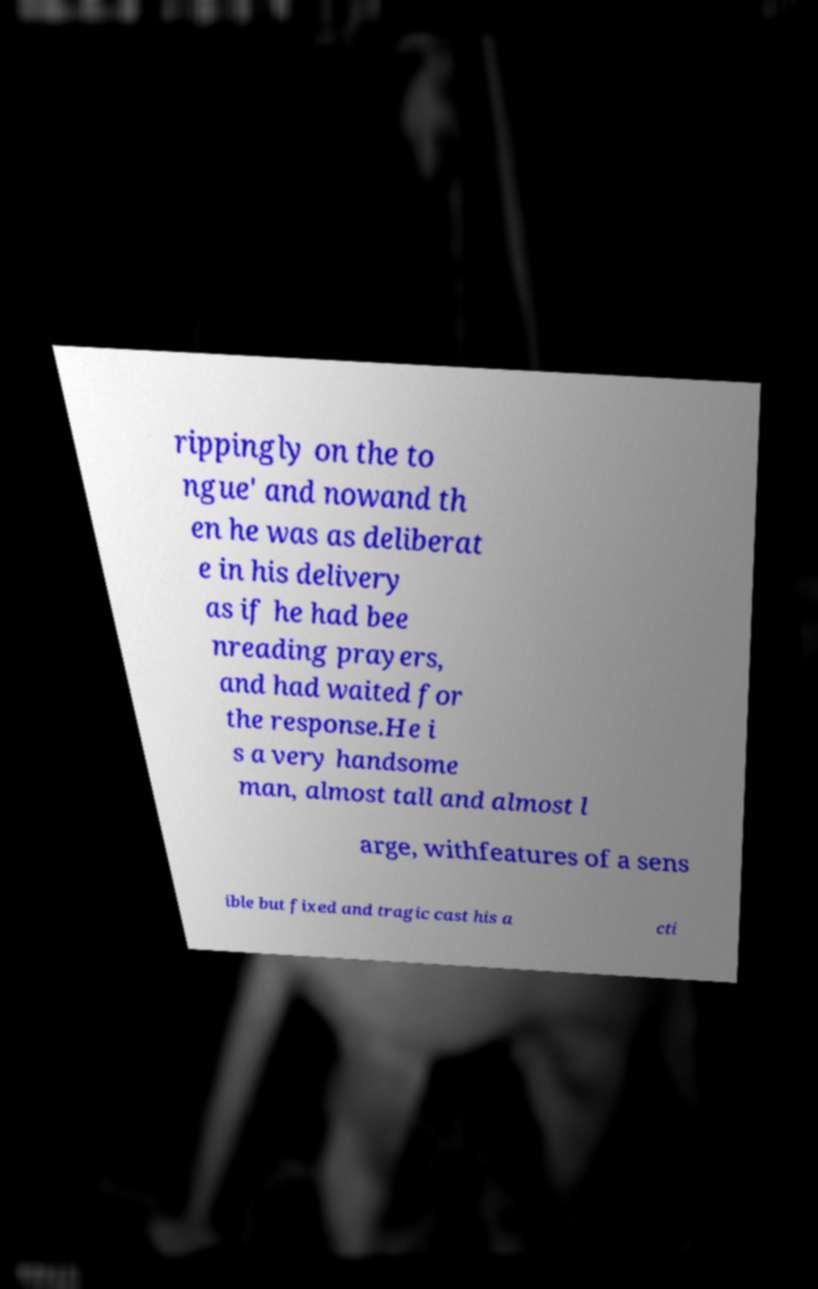Please identify and transcribe the text found in this image. rippingly on the to ngue' and nowand th en he was as deliberat e in his delivery as if he had bee nreading prayers, and had waited for the response.He i s a very handsome man, almost tall and almost l arge, withfeatures of a sens ible but fixed and tragic cast his a cti 